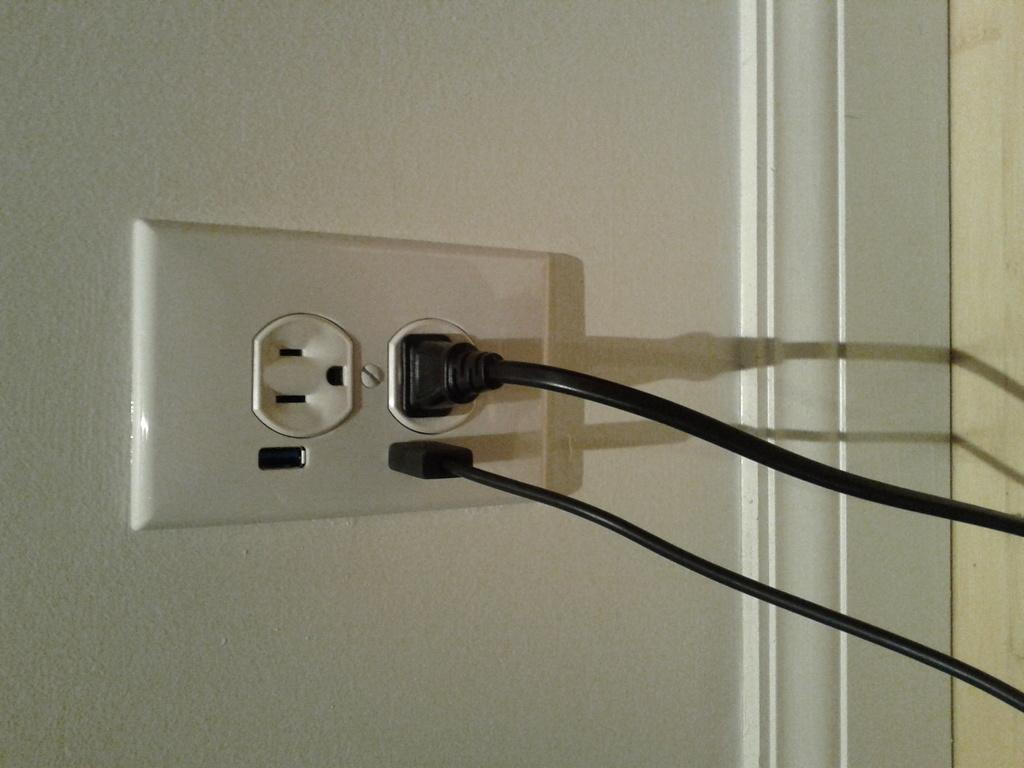What can be seen connected to the socket in the image? The wires are plugged into a socket in the image. Where is the socket attached in the image? The socket is fixed to the wall in the image. What type of flooring is visible in the image? There is a wooden floor visible in the image. Can you tell me how many experts are present in the image? There is no expert present in the image; it features wires plugged into a socket that is fixed to the wall. Is there any smoke visible in the image? There is no smoke present in the image. 